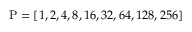<formula> <loc_0><loc_0><loc_500><loc_500>P = [ 1 , 2 , 4 , 8 , 1 6 , 3 2 , 6 4 , 1 2 8 , 2 5 6 ]</formula> 